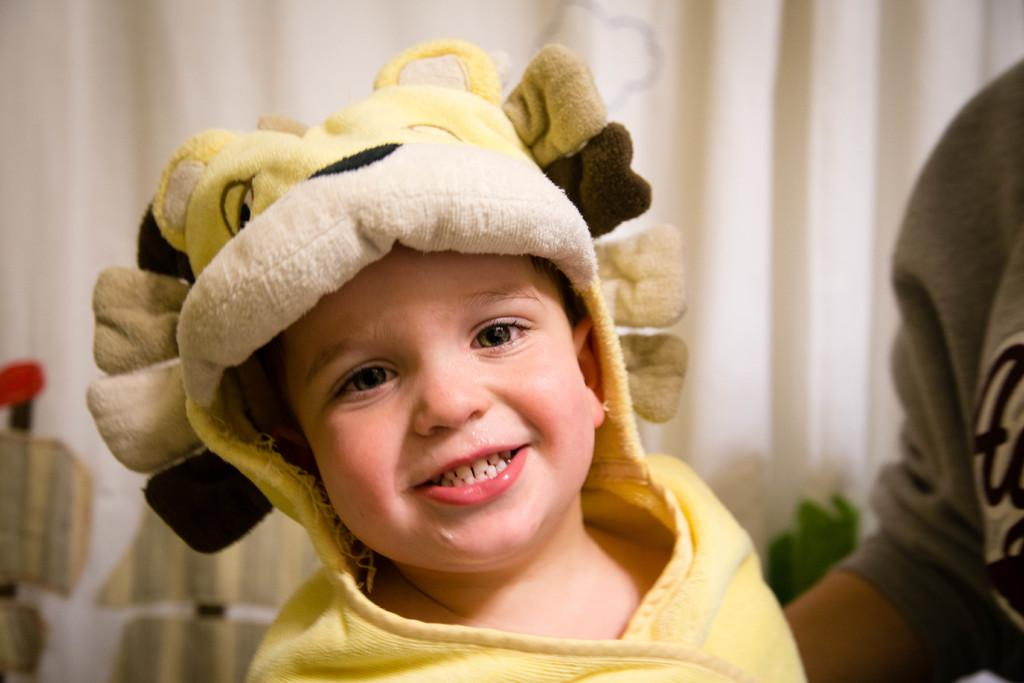What is the main subject of the image? The main subject of the image is a kid. What is the kid doing in the image? The kid is smiling in the image. What can be seen in the background of the image? There is a curtain in the background of the image. What type of bread can be seen hanging from the curtain in the image? There is no bread present in the image, and it is not hanging from the curtain. 